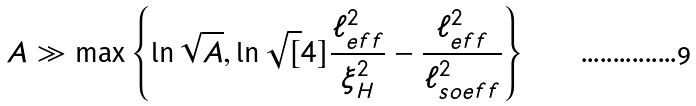<formula> <loc_0><loc_0><loc_500><loc_500>A \gg \max \left \{ \ln \sqrt { A } , \ln \sqrt { [ } 4 ] { \frac { \ell _ { e f f } ^ { 2 } } { \xi _ { H } ^ { 2 } } - \frac { \ell _ { e f f } ^ { 2 } } { \ell _ { s o e f f } ^ { 2 } } } \right \}</formula> 